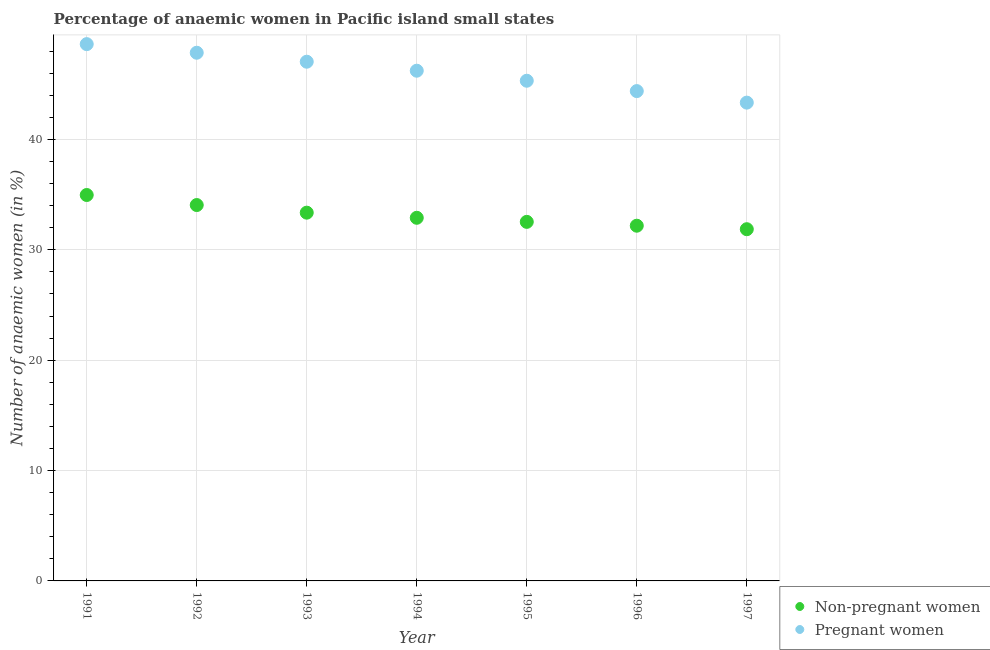How many different coloured dotlines are there?
Your answer should be very brief. 2. What is the percentage of pregnant anaemic women in 1996?
Your answer should be very brief. 44.38. Across all years, what is the maximum percentage of pregnant anaemic women?
Your answer should be compact. 48.64. Across all years, what is the minimum percentage of non-pregnant anaemic women?
Make the answer very short. 31.87. In which year was the percentage of non-pregnant anaemic women minimum?
Offer a very short reply. 1997. What is the total percentage of non-pregnant anaemic women in the graph?
Provide a succinct answer. 231.88. What is the difference between the percentage of pregnant anaemic women in 1996 and that in 1997?
Give a very brief answer. 1.05. What is the difference between the percentage of pregnant anaemic women in 1997 and the percentage of non-pregnant anaemic women in 1994?
Your answer should be compact. 10.43. What is the average percentage of pregnant anaemic women per year?
Make the answer very short. 46.11. In the year 1996, what is the difference between the percentage of non-pregnant anaemic women and percentage of pregnant anaemic women?
Make the answer very short. -12.2. What is the ratio of the percentage of pregnant anaemic women in 1992 to that in 1994?
Ensure brevity in your answer.  1.04. Is the difference between the percentage of non-pregnant anaemic women in 1994 and 1997 greater than the difference between the percentage of pregnant anaemic women in 1994 and 1997?
Offer a very short reply. No. What is the difference between the highest and the second highest percentage of non-pregnant anaemic women?
Offer a very short reply. 0.91. What is the difference between the highest and the lowest percentage of non-pregnant anaemic women?
Your answer should be very brief. 3.1. Is the sum of the percentage of non-pregnant anaemic women in 1992 and 1994 greater than the maximum percentage of pregnant anaemic women across all years?
Provide a short and direct response. Yes. Is the percentage of pregnant anaemic women strictly greater than the percentage of non-pregnant anaemic women over the years?
Provide a succinct answer. Yes. Does the graph contain any zero values?
Make the answer very short. No. How many legend labels are there?
Offer a terse response. 2. How are the legend labels stacked?
Make the answer very short. Vertical. What is the title of the graph?
Give a very brief answer. Percentage of anaemic women in Pacific island small states. What is the label or title of the X-axis?
Make the answer very short. Year. What is the label or title of the Y-axis?
Offer a terse response. Number of anaemic women (in %). What is the Number of anaemic women (in %) in Non-pregnant women in 1991?
Keep it short and to the point. 34.97. What is the Number of anaemic women (in %) in Pregnant women in 1991?
Your response must be concise. 48.64. What is the Number of anaemic women (in %) in Non-pregnant women in 1992?
Provide a short and direct response. 34.06. What is the Number of anaemic women (in %) in Pregnant women in 1992?
Provide a short and direct response. 47.86. What is the Number of anaemic women (in %) in Non-pregnant women in 1993?
Offer a very short reply. 33.37. What is the Number of anaemic women (in %) in Pregnant women in 1993?
Provide a succinct answer. 47.04. What is the Number of anaemic women (in %) of Non-pregnant women in 1994?
Offer a terse response. 32.9. What is the Number of anaemic women (in %) of Pregnant women in 1994?
Offer a very short reply. 46.23. What is the Number of anaemic women (in %) in Non-pregnant women in 1995?
Your answer should be compact. 32.53. What is the Number of anaemic women (in %) of Pregnant women in 1995?
Give a very brief answer. 45.32. What is the Number of anaemic women (in %) in Non-pregnant women in 1996?
Give a very brief answer. 32.18. What is the Number of anaemic women (in %) of Pregnant women in 1996?
Offer a terse response. 44.38. What is the Number of anaemic women (in %) in Non-pregnant women in 1997?
Your answer should be compact. 31.87. What is the Number of anaemic women (in %) of Pregnant women in 1997?
Provide a short and direct response. 43.34. Across all years, what is the maximum Number of anaemic women (in %) of Non-pregnant women?
Your response must be concise. 34.97. Across all years, what is the maximum Number of anaemic women (in %) in Pregnant women?
Your answer should be very brief. 48.64. Across all years, what is the minimum Number of anaemic women (in %) in Non-pregnant women?
Provide a succinct answer. 31.87. Across all years, what is the minimum Number of anaemic women (in %) of Pregnant women?
Provide a succinct answer. 43.34. What is the total Number of anaemic women (in %) in Non-pregnant women in the graph?
Offer a terse response. 231.88. What is the total Number of anaemic women (in %) of Pregnant women in the graph?
Your answer should be compact. 322.8. What is the difference between the Number of anaemic women (in %) in Non-pregnant women in 1991 and that in 1992?
Offer a terse response. 0.91. What is the difference between the Number of anaemic women (in %) in Pregnant women in 1991 and that in 1992?
Offer a terse response. 0.78. What is the difference between the Number of anaemic women (in %) of Non-pregnant women in 1991 and that in 1993?
Provide a succinct answer. 1.6. What is the difference between the Number of anaemic women (in %) of Pregnant women in 1991 and that in 1993?
Keep it short and to the point. 1.59. What is the difference between the Number of anaemic women (in %) of Non-pregnant women in 1991 and that in 1994?
Give a very brief answer. 2.06. What is the difference between the Number of anaemic women (in %) of Pregnant women in 1991 and that in 1994?
Provide a succinct answer. 2.41. What is the difference between the Number of anaemic women (in %) of Non-pregnant women in 1991 and that in 1995?
Your response must be concise. 2.43. What is the difference between the Number of anaemic women (in %) in Pregnant women in 1991 and that in 1995?
Provide a succinct answer. 3.32. What is the difference between the Number of anaemic women (in %) in Non-pregnant women in 1991 and that in 1996?
Ensure brevity in your answer.  2.78. What is the difference between the Number of anaemic women (in %) of Pregnant women in 1991 and that in 1996?
Keep it short and to the point. 4.25. What is the difference between the Number of anaemic women (in %) in Non-pregnant women in 1991 and that in 1997?
Provide a short and direct response. 3.1. What is the difference between the Number of anaemic women (in %) in Pregnant women in 1991 and that in 1997?
Provide a succinct answer. 5.3. What is the difference between the Number of anaemic women (in %) in Non-pregnant women in 1992 and that in 1993?
Offer a very short reply. 0.69. What is the difference between the Number of anaemic women (in %) in Pregnant women in 1992 and that in 1993?
Provide a short and direct response. 0.81. What is the difference between the Number of anaemic women (in %) in Non-pregnant women in 1992 and that in 1994?
Offer a terse response. 1.15. What is the difference between the Number of anaemic women (in %) of Pregnant women in 1992 and that in 1994?
Offer a terse response. 1.63. What is the difference between the Number of anaemic women (in %) in Non-pregnant women in 1992 and that in 1995?
Your answer should be compact. 1.52. What is the difference between the Number of anaemic women (in %) of Pregnant women in 1992 and that in 1995?
Your response must be concise. 2.54. What is the difference between the Number of anaemic women (in %) of Non-pregnant women in 1992 and that in 1996?
Keep it short and to the point. 1.87. What is the difference between the Number of anaemic women (in %) in Pregnant women in 1992 and that in 1996?
Give a very brief answer. 3.47. What is the difference between the Number of anaemic women (in %) in Non-pregnant women in 1992 and that in 1997?
Your answer should be compact. 2.19. What is the difference between the Number of anaemic women (in %) of Pregnant women in 1992 and that in 1997?
Keep it short and to the point. 4.52. What is the difference between the Number of anaemic women (in %) in Non-pregnant women in 1993 and that in 1994?
Give a very brief answer. 0.46. What is the difference between the Number of anaemic women (in %) in Pregnant women in 1993 and that in 1994?
Give a very brief answer. 0.82. What is the difference between the Number of anaemic women (in %) of Non-pregnant women in 1993 and that in 1995?
Keep it short and to the point. 0.83. What is the difference between the Number of anaemic women (in %) in Pregnant women in 1993 and that in 1995?
Offer a very short reply. 1.72. What is the difference between the Number of anaemic women (in %) of Non-pregnant women in 1993 and that in 1996?
Give a very brief answer. 1.18. What is the difference between the Number of anaemic women (in %) of Pregnant women in 1993 and that in 1996?
Offer a very short reply. 2.66. What is the difference between the Number of anaemic women (in %) of Non-pregnant women in 1993 and that in 1997?
Provide a succinct answer. 1.5. What is the difference between the Number of anaemic women (in %) in Pregnant women in 1993 and that in 1997?
Offer a very short reply. 3.71. What is the difference between the Number of anaemic women (in %) of Non-pregnant women in 1994 and that in 1995?
Ensure brevity in your answer.  0.37. What is the difference between the Number of anaemic women (in %) of Pregnant women in 1994 and that in 1995?
Offer a terse response. 0.91. What is the difference between the Number of anaemic women (in %) of Non-pregnant women in 1994 and that in 1996?
Your answer should be very brief. 0.72. What is the difference between the Number of anaemic women (in %) of Pregnant women in 1994 and that in 1996?
Keep it short and to the point. 1.85. What is the difference between the Number of anaemic women (in %) of Non-pregnant women in 1994 and that in 1997?
Offer a very short reply. 1.03. What is the difference between the Number of anaemic women (in %) in Pregnant women in 1994 and that in 1997?
Your answer should be very brief. 2.89. What is the difference between the Number of anaemic women (in %) in Non-pregnant women in 1995 and that in 1996?
Provide a short and direct response. 0.35. What is the difference between the Number of anaemic women (in %) in Pregnant women in 1995 and that in 1996?
Make the answer very short. 0.94. What is the difference between the Number of anaemic women (in %) in Non-pregnant women in 1995 and that in 1997?
Offer a very short reply. 0.67. What is the difference between the Number of anaemic women (in %) in Pregnant women in 1995 and that in 1997?
Your response must be concise. 1.98. What is the difference between the Number of anaemic women (in %) in Non-pregnant women in 1996 and that in 1997?
Ensure brevity in your answer.  0.32. What is the difference between the Number of anaemic women (in %) in Pregnant women in 1996 and that in 1997?
Your answer should be very brief. 1.05. What is the difference between the Number of anaemic women (in %) of Non-pregnant women in 1991 and the Number of anaemic women (in %) of Pregnant women in 1992?
Ensure brevity in your answer.  -12.89. What is the difference between the Number of anaemic women (in %) of Non-pregnant women in 1991 and the Number of anaemic women (in %) of Pregnant women in 1993?
Offer a terse response. -12.08. What is the difference between the Number of anaemic women (in %) in Non-pregnant women in 1991 and the Number of anaemic women (in %) in Pregnant women in 1994?
Provide a short and direct response. -11.26. What is the difference between the Number of anaemic women (in %) in Non-pregnant women in 1991 and the Number of anaemic women (in %) in Pregnant women in 1995?
Ensure brevity in your answer.  -10.35. What is the difference between the Number of anaemic women (in %) in Non-pregnant women in 1991 and the Number of anaemic women (in %) in Pregnant women in 1996?
Your response must be concise. -9.42. What is the difference between the Number of anaemic women (in %) in Non-pregnant women in 1991 and the Number of anaemic women (in %) in Pregnant women in 1997?
Provide a succinct answer. -8.37. What is the difference between the Number of anaemic women (in %) of Non-pregnant women in 1992 and the Number of anaemic women (in %) of Pregnant women in 1993?
Provide a short and direct response. -12.99. What is the difference between the Number of anaemic women (in %) in Non-pregnant women in 1992 and the Number of anaemic women (in %) in Pregnant women in 1994?
Provide a short and direct response. -12.17. What is the difference between the Number of anaemic women (in %) of Non-pregnant women in 1992 and the Number of anaemic women (in %) of Pregnant women in 1995?
Your answer should be very brief. -11.26. What is the difference between the Number of anaemic women (in %) of Non-pregnant women in 1992 and the Number of anaemic women (in %) of Pregnant women in 1996?
Your answer should be very brief. -10.33. What is the difference between the Number of anaemic women (in %) in Non-pregnant women in 1992 and the Number of anaemic women (in %) in Pregnant women in 1997?
Provide a short and direct response. -9.28. What is the difference between the Number of anaemic women (in %) of Non-pregnant women in 1993 and the Number of anaemic women (in %) of Pregnant women in 1994?
Provide a short and direct response. -12.86. What is the difference between the Number of anaemic women (in %) of Non-pregnant women in 1993 and the Number of anaemic women (in %) of Pregnant women in 1995?
Give a very brief answer. -11.95. What is the difference between the Number of anaemic women (in %) of Non-pregnant women in 1993 and the Number of anaemic women (in %) of Pregnant women in 1996?
Offer a very short reply. -11.02. What is the difference between the Number of anaemic women (in %) in Non-pregnant women in 1993 and the Number of anaemic women (in %) in Pregnant women in 1997?
Your answer should be compact. -9.97. What is the difference between the Number of anaemic women (in %) in Non-pregnant women in 1994 and the Number of anaemic women (in %) in Pregnant women in 1995?
Your response must be concise. -12.42. What is the difference between the Number of anaemic women (in %) in Non-pregnant women in 1994 and the Number of anaemic women (in %) in Pregnant women in 1996?
Make the answer very short. -11.48. What is the difference between the Number of anaemic women (in %) in Non-pregnant women in 1994 and the Number of anaemic women (in %) in Pregnant women in 1997?
Your answer should be compact. -10.43. What is the difference between the Number of anaemic women (in %) of Non-pregnant women in 1995 and the Number of anaemic women (in %) of Pregnant women in 1996?
Your answer should be very brief. -11.85. What is the difference between the Number of anaemic women (in %) of Non-pregnant women in 1995 and the Number of anaemic women (in %) of Pregnant women in 1997?
Provide a succinct answer. -10.8. What is the difference between the Number of anaemic women (in %) in Non-pregnant women in 1996 and the Number of anaemic women (in %) in Pregnant women in 1997?
Your answer should be very brief. -11.15. What is the average Number of anaemic women (in %) of Non-pregnant women per year?
Make the answer very short. 33.13. What is the average Number of anaemic women (in %) in Pregnant women per year?
Provide a succinct answer. 46.11. In the year 1991, what is the difference between the Number of anaemic women (in %) of Non-pregnant women and Number of anaemic women (in %) of Pregnant women?
Your answer should be very brief. -13.67. In the year 1992, what is the difference between the Number of anaemic women (in %) of Non-pregnant women and Number of anaemic women (in %) of Pregnant women?
Offer a very short reply. -13.8. In the year 1993, what is the difference between the Number of anaemic women (in %) in Non-pregnant women and Number of anaemic women (in %) in Pregnant women?
Give a very brief answer. -13.68. In the year 1994, what is the difference between the Number of anaemic women (in %) in Non-pregnant women and Number of anaemic women (in %) in Pregnant women?
Give a very brief answer. -13.33. In the year 1995, what is the difference between the Number of anaemic women (in %) in Non-pregnant women and Number of anaemic women (in %) in Pregnant women?
Provide a succinct answer. -12.79. In the year 1996, what is the difference between the Number of anaemic women (in %) in Non-pregnant women and Number of anaemic women (in %) in Pregnant women?
Ensure brevity in your answer.  -12.2. In the year 1997, what is the difference between the Number of anaemic women (in %) in Non-pregnant women and Number of anaemic women (in %) in Pregnant women?
Your response must be concise. -11.47. What is the ratio of the Number of anaemic women (in %) in Non-pregnant women in 1991 to that in 1992?
Your response must be concise. 1.03. What is the ratio of the Number of anaemic women (in %) of Pregnant women in 1991 to that in 1992?
Provide a short and direct response. 1.02. What is the ratio of the Number of anaemic women (in %) in Non-pregnant women in 1991 to that in 1993?
Your answer should be very brief. 1.05. What is the ratio of the Number of anaemic women (in %) of Pregnant women in 1991 to that in 1993?
Provide a succinct answer. 1.03. What is the ratio of the Number of anaemic women (in %) in Non-pregnant women in 1991 to that in 1994?
Keep it short and to the point. 1.06. What is the ratio of the Number of anaemic women (in %) in Pregnant women in 1991 to that in 1994?
Your answer should be very brief. 1.05. What is the ratio of the Number of anaemic women (in %) in Non-pregnant women in 1991 to that in 1995?
Your answer should be compact. 1.07. What is the ratio of the Number of anaemic women (in %) in Pregnant women in 1991 to that in 1995?
Keep it short and to the point. 1.07. What is the ratio of the Number of anaemic women (in %) in Non-pregnant women in 1991 to that in 1996?
Provide a short and direct response. 1.09. What is the ratio of the Number of anaemic women (in %) in Pregnant women in 1991 to that in 1996?
Provide a succinct answer. 1.1. What is the ratio of the Number of anaemic women (in %) in Non-pregnant women in 1991 to that in 1997?
Provide a succinct answer. 1.1. What is the ratio of the Number of anaemic women (in %) of Pregnant women in 1991 to that in 1997?
Ensure brevity in your answer.  1.12. What is the ratio of the Number of anaemic women (in %) in Non-pregnant women in 1992 to that in 1993?
Your answer should be very brief. 1.02. What is the ratio of the Number of anaemic women (in %) of Pregnant women in 1992 to that in 1993?
Your response must be concise. 1.02. What is the ratio of the Number of anaemic women (in %) of Non-pregnant women in 1992 to that in 1994?
Your response must be concise. 1.04. What is the ratio of the Number of anaemic women (in %) in Pregnant women in 1992 to that in 1994?
Offer a very short reply. 1.04. What is the ratio of the Number of anaemic women (in %) in Non-pregnant women in 1992 to that in 1995?
Your response must be concise. 1.05. What is the ratio of the Number of anaemic women (in %) in Pregnant women in 1992 to that in 1995?
Your response must be concise. 1.06. What is the ratio of the Number of anaemic women (in %) in Non-pregnant women in 1992 to that in 1996?
Ensure brevity in your answer.  1.06. What is the ratio of the Number of anaemic women (in %) of Pregnant women in 1992 to that in 1996?
Ensure brevity in your answer.  1.08. What is the ratio of the Number of anaemic women (in %) of Non-pregnant women in 1992 to that in 1997?
Keep it short and to the point. 1.07. What is the ratio of the Number of anaemic women (in %) of Pregnant women in 1992 to that in 1997?
Keep it short and to the point. 1.1. What is the ratio of the Number of anaemic women (in %) in Non-pregnant women in 1993 to that in 1994?
Your response must be concise. 1.01. What is the ratio of the Number of anaemic women (in %) in Pregnant women in 1993 to that in 1994?
Offer a very short reply. 1.02. What is the ratio of the Number of anaemic women (in %) of Non-pregnant women in 1993 to that in 1995?
Your response must be concise. 1.03. What is the ratio of the Number of anaemic women (in %) in Pregnant women in 1993 to that in 1995?
Provide a succinct answer. 1.04. What is the ratio of the Number of anaemic women (in %) of Non-pregnant women in 1993 to that in 1996?
Your answer should be very brief. 1.04. What is the ratio of the Number of anaemic women (in %) in Pregnant women in 1993 to that in 1996?
Offer a very short reply. 1.06. What is the ratio of the Number of anaemic women (in %) in Non-pregnant women in 1993 to that in 1997?
Keep it short and to the point. 1.05. What is the ratio of the Number of anaemic women (in %) of Pregnant women in 1993 to that in 1997?
Your answer should be compact. 1.09. What is the ratio of the Number of anaemic women (in %) in Non-pregnant women in 1994 to that in 1995?
Your response must be concise. 1.01. What is the ratio of the Number of anaemic women (in %) in Pregnant women in 1994 to that in 1995?
Your answer should be very brief. 1.02. What is the ratio of the Number of anaemic women (in %) in Non-pregnant women in 1994 to that in 1996?
Provide a short and direct response. 1.02. What is the ratio of the Number of anaemic women (in %) in Pregnant women in 1994 to that in 1996?
Your answer should be very brief. 1.04. What is the ratio of the Number of anaemic women (in %) of Non-pregnant women in 1994 to that in 1997?
Ensure brevity in your answer.  1.03. What is the ratio of the Number of anaemic women (in %) of Pregnant women in 1994 to that in 1997?
Make the answer very short. 1.07. What is the ratio of the Number of anaemic women (in %) in Non-pregnant women in 1995 to that in 1996?
Offer a very short reply. 1.01. What is the ratio of the Number of anaemic women (in %) in Pregnant women in 1995 to that in 1996?
Provide a succinct answer. 1.02. What is the ratio of the Number of anaemic women (in %) in Non-pregnant women in 1995 to that in 1997?
Provide a short and direct response. 1.02. What is the ratio of the Number of anaemic women (in %) in Pregnant women in 1995 to that in 1997?
Ensure brevity in your answer.  1.05. What is the ratio of the Number of anaemic women (in %) of Non-pregnant women in 1996 to that in 1997?
Keep it short and to the point. 1.01. What is the ratio of the Number of anaemic women (in %) of Pregnant women in 1996 to that in 1997?
Provide a short and direct response. 1.02. What is the difference between the highest and the second highest Number of anaemic women (in %) of Non-pregnant women?
Provide a short and direct response. 0.91. What is the difference between the highest and the second highest Number of anaemic women (in %) in Pregnant women?
Your answer should be compact. 0.78. What is the difference between the highest and the lowest Number of anaemic women (in %) of Non-pregnant women?
Your response must be concise. 3.1. What is the difference between the highest and the lowest Number of anaemic women (in %) of Pregnant women?
Ensure brevity in your answer.  5.3. 